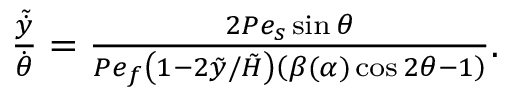<formula> <loc_0><loc_0><loc_500><loc_500>\begin{array} { r } { \frac { \tilde { \dot { y } } } { \dot { \theta } } = \frac { 2 P e _ { s } \sin \theta } { P e _ { f } \left ( 1 - 2 \tilde { y } / \tilde { H } \right ) \left ( \beta ( \alpha ) \cos 2 \theta - 1 \right ) } . } \end{array}</formula> 